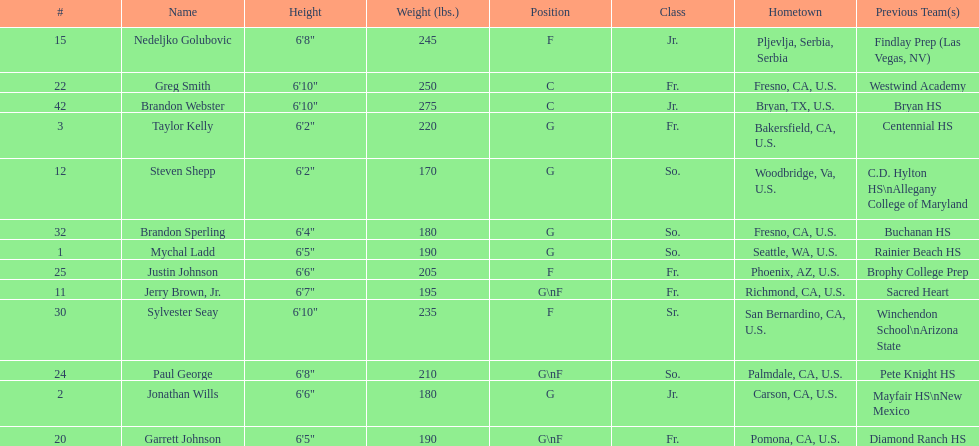Who weighs the most on the team? Brandon Webster. 